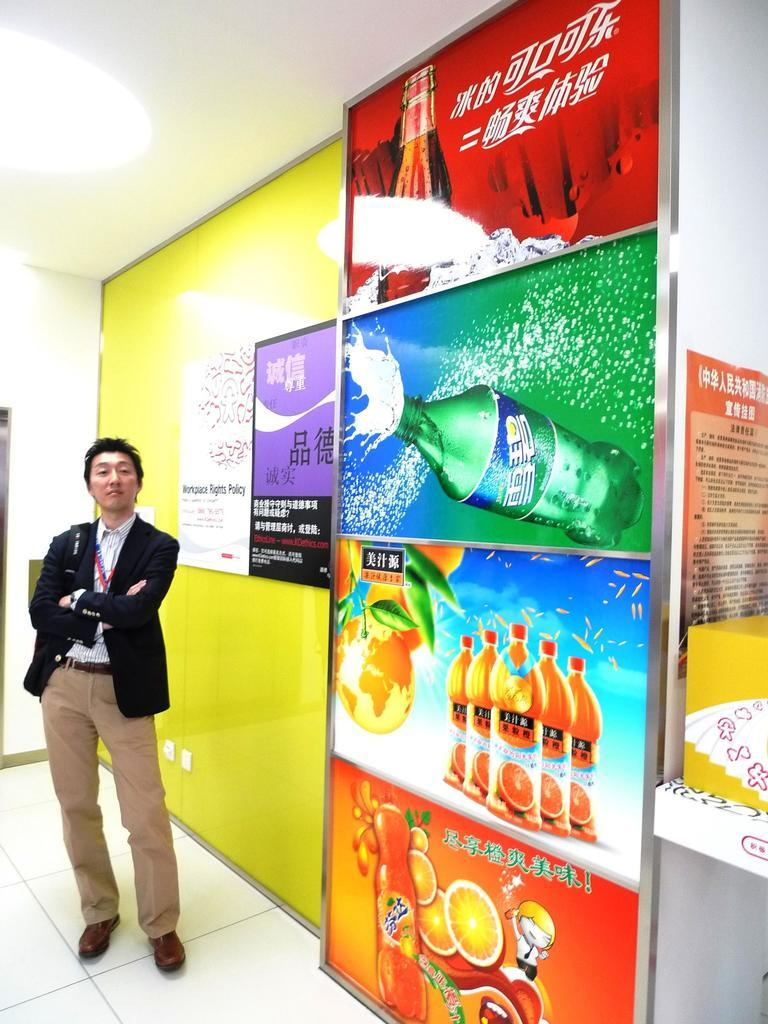What is the main subject of the image? There is a man standing in the image. What is the man wearing in the image? The man is wearing a blazer. What can be seen on the wall in the image? There are soft drink advertisements on the wall. What type of hill can be seen in the background of the image? There is no hill visible in the image; it only shows a man standing and a wall with soft drink advertisements. 